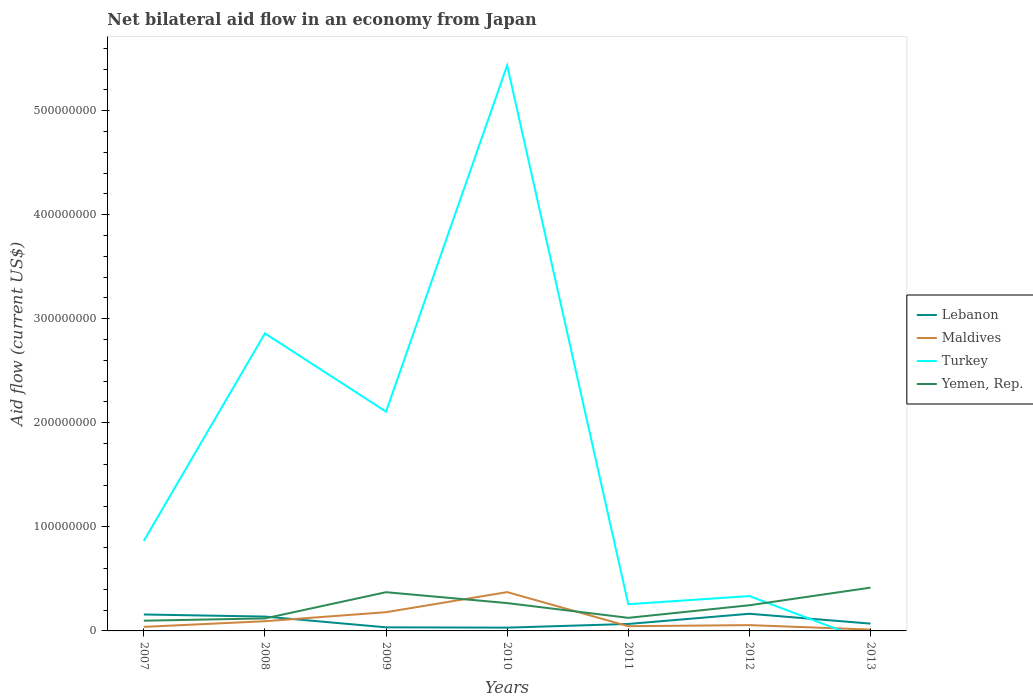How many different coloured lines are there?
Ensure brevity in your answer.  4. Is the number of lines equal to the number of legend labels?
Keep it short and to the point. No. Across all years, what is the maximum net bilateral aid flow in Lebanon?
Give a very brief answer. 3.15e+06. What is the total net bilateral aid flow in Yemen, Rep. in the graph?
Offer a very short reply. -2.96e+07. What is the difference between the highest and the second highest net bilateral aid flow in Turkey?
Make the answer very short. 5.43e+08. How many lines are there?
Make the answer very short. 4. How many years are there in the graph?
Provide a short and direct response. 7. What is the difference between two consecutive major ticks on the Y-axis?
Provide a succinct answer. 1.00e+08. Are the values on the major ticks of Y-axis written in scientific E-notation?
Make the answer very short. No. Where does the legend appear in the graph?
Make the answer very short. Center right. How are the legend labels stacked?
Ensure brevity in your answer.  Vertical. What is the title of the graph?
Your answer should be very brief. Net bilateral aid flow in an economy from Japan. What is the label or title of the X-axis?
Give a very brief answer. Years. What is the Aid flow (current US$) of Lebanon in 2007?
Offer a terse response. 1.58e+07. What is the Aid flow (current US$) of Maldives in 2007?
Your answer should be very brief. 3.89e+06. What is the Aid flow (current US$) of Turkey in 2007?
Ensure brevity in your answer.  8.66e+07. What is the Aid flow (current US$) of Yemen, Rep. in 2007?
Your answer should be very brief. 9.82e+06. What is the Aid flow (current US$) in Lebanon in 2008?
Your response must be concise. 1.38e+07. What is the Aid flow (current US$) in Maldives in 2008?
Keep it short and to the point. 9.32e+06. What is the Aid flow (current US$) of Turkey in 2008?
Give a very brief answer. 2.86e+08. What is the Aid flow (current US$) in Yemen, Rep. in 2008?
Your response must be concise. 1.20e+07. What is the Aid flow (current US$) of Lebanon in 2009?
Offer a very short reply. 3.46e+06. What is the Aid flow (current US$) in Maldives in 2009?
Offer a very short reply. 1.80e+07. What is the Aid flow (current US$) of Turkey in 2009?
Provide a succinct answer. 2.11e+08. What is the Aid flow (current US$) in Yemen, Rep. in 2009?
Make the answer very short. 3.72e+07. What is the Aid flow (current US$) of Lebanon in 2010?
Provide a succinct answer. 3.15e+06. What is the Aid flow (current US$) of Maldives in 2010?
Provide a succinct answer. 3.73e+07. What is the Aid flow (current US$) of Turkey in 2010?
Give a very brief answer. 5.43e+08. What is the Aid flow (current US$) of Yemen, Rep. in 2010?
Offer a very short reply. 2.67e+07. What is the Aid flow (current US$) of Lebanon in 2011?
Keep it short and to the point. 6.69e+06. What is the Aid flow (current US$) of Maldives in 2011?
Keep it short and to the point. 4.55e+06. What is the Aid flow (current US$) of Turkey in 2011?
Your answer should be very brief. 2.57e+07. What is the Aid flow (current US$) of Yemen, Rep. in 2011?
Your response must be concise. 1.26e+07. What is the Aid flow (current US$) of Lebanon in 2012?
Provide a short and direct response. 1.65e+07. What is the Aid flow (current US$) of Maldives in 2012?
Your answer should be compact. 5.57e+06. What is the Aid flow (current US$) of Turkey in 2012?
Provide a succinct answer. 3.35e+07. What is the Aid flow (current US$) of Yemen, Rep. in 2012?
Make the answer very short. 2.47e+07. What is the Aid flow (current US$) in Lebanon in 2013?
Offer a terse response. 7.03e+06. What is the Aid flow (current US$) in Maldives in 2013?
Provide a succinct answer. 1.27e+06. What is the Aid flow (current US$) in Turkey in 2013?
Offer a very short reply. 0. What is the Aid flow (current US$) in Yemen, Rep. in 2013?
Ensure brevity in your answer.  4.16e+07. Across all years, what is the maximum Aid flow (current US$) in Lebanon?
Your answer should be compact. 1.65e+07. Across all years, what is the maximum Aid flow (current US$) in Maldives?
Make the answer very short. 3.73e+07. Across all years, what is the maximum Aid flow (current US$) in Turkey?
Give a very brief answer. 5.43e+08. Across all years, what is the maximum Aid flow (current US$) of Yemen, Rep.?
Offer a terse response. 4.16e+07. Across all years, what is the minimum Aid flow (current US$) of Lebanon?
Your answer should be very brief. 3.15e+06. Across all years, what is the minimum Aid flow (current US$) of Maldives?
Ensure brevity in your answer.  1.27e+06. Across all years, what is the minimum Aid flow (current US$) in Yemen, Rep.?
Make the answer very short. 9.82e+06. What is the total Aid flow (current US$) in Lebanon in the graph?
Offer a very short reply. 6.64e+07. What is the total Aid flow (current US$) of Maldives in the graph?
Offer a terse response. 7.99e+07. What is the total Aid flow (current US$) of Turkey in the graph?
Keep it short and to the point. 1.19e+09. What is the total Aid flow (current US$) of Yemen, Rep. in the graph?
Provide a short and direct response. 1.65e+08. What is the difference between the Aid flow (current US$) of Lebanon in 2007 and that in 2008?
Ensure brevity in your answer.  2.01e+06. What is the difference between the Aid flow (current US$) of Maldives in 2007 and that in 2008?
Give a very brief answer. -5.43e+06. What is the difference between the Aid flow (current US$) in Turkey in 2007 and that in 2008?
Make the answer very short. -1.99e+08. What is the difference between the Aid flow (current US$) in Yemen, Rep. in 2007 and that in 2008?
Give a very brief answer. -2.20e+06. What is the difference between the Aid flow (current US$) of Lebanon in 2007 and that in 2009?
Make the answer very short. 1.23e+07. What is the difference between the Aid flow (current US$) in Maldives in 2007 and that in 2009?
Your response must be concise. -1.41e+07. What is the difference between the Aid flow (current US$) in Turkey in 2007 and that in 2009?
Provide a succinct answer. -1.24e+08. What is the difference between the Aid flow (current US$) in Yemen, Rep. in 2007 and that in 2009?
Ensure brevity in your answer.  -2.74e+07. What is the difference between the Aid flow (current US$) of Lebanon in 2007 and that in 2010?
Keep it short and to the point. 1.26e+07. What is the difference between the Aid flow (current US$) in Maldives in 2007 and that in 2010?
Your response must be concise. -3.34e+07. What is the difference between the Aid flow (current US$) of Turkey in 2007 and that in 2010?
Provide a short and direct response. -4.57e+08. What is the difference between the Aid flow (current US$) in Yemen, Rep. in 2007 and that in 2010?
Offer a terse response. -1.69e+07. What is the difference between the Aid flow (current US$) of Lebanon in 2007 and that in 2011?
Your response must be concise. 9.11e+06. What is the difference between the Aid flow (current US$) in Maldives in 2007 and that in 2011?
Offer a terse response. -6.60e+05. What is the difference between the Aid flow (current US$) of Turkey in 2007 and that in 2011?
Provide a short and direct response. 6.09e+07. What is the difference between the Aid flow (current US$) in Yemen, Rep. in 2007 and that in 2011?
Ensure brevity in your answer.  -2.76e+06. What is the difference between the Aid flow (current US$) of Lebanon in 2007 and that in 2012?
Your answer should be very brief. -6.90e+05. What is the difference between the Aid flow (current US$) in Maldives in 2007 and that in 2012?
Provide a succinct answer. -1.68e+06. What is the difference between the Aid flow (current US$) of Turkey in 2007 and that in 2012?
Your answer should be compact. 5.30e+07. What is the difference between the Aid flow (current US$) of Yemen, Rep. in 2007 and that in 2012?
Keep it short and to the point. -1.48e+07. What is the difference between the Aid flow (current US$) of Lebanon in 2007 and that in 2013?
Your answer should be compact. 8.77e+06. What is the difference between the Aid flow (current US$) in Maldives in 2007 and that in 2013?
Make the answer very short. 2.62e+06. What is the difference between the Aid flow (current US$) of Yemen, Rep. in 2007 and that in 2013?
Keep it short and to the point. -3.18e+07. What is the difference between the Aid flow (current US$) in Lebanon in 2008 and that in 2009?
Give a very brief answer. 1.03e+07. What is the difference between the Aid flow (current US$) of Maldives in 2008 and that in 2009?
Keep it short and to the point. -8.67e+06. What is the difference between the Aid flow (current US$) of Turkey in 2008 and that in 2009?
Ensure brevity in your answer.  7.52e+07. What is the difference between the Aid flow (current US$) in Yemen, Rep. in 2008 and that in 2009?
Your response must be concise. -2.52e+07. What is the difference between the Aid flow (current US$) of Lebanon in 2008 and that in 2010?
Your answer should be compact. 1.06e+07. What is the difference between the Aid flow (current US$) in Maldives in 2008 and that in 2010?
Provide a short and direct response. -2.80e+07. What is the difference between the Aid flow (current US$) of Turkey in 2008 and that in 2010?
Give a very brief answer. -2.58e+08. What is the difference between the Aid flow (current US$) in Yemen, Rep. in 2008 and that in 2010?
Your answer should be compact. -1.47e+07. What is the difference between the Aid flow (current US$) of Lebanon in 2008 and that in 2011?
Ensure brevity in your answer.  7.10e+06. What is the difference between the Aid flow (current US$) in Maldives in 2008 and that in 2011?
Your response must be concise. 4.77e+06. What is the difference between the Aid flow (current US$) in Turkey in 2008 and that in 2011?
Keep it short and to the point. 2.60e+08. What is the difference between the Aid flow (current US$) of Yemen, Rep. in 2008 and that in 2011?
Your response must be concise. -5.60e+05. What is the difference between the Aid flow (current US$) in Lebanon in 2008 and that in 2012?
Give a very brief answer. -2.70e+06. What is the difference between the Aid flow (current US$) of Maldives in 2008 and that in 2012?
Your response must be concise. 3.75e+06. What is the difference between the Aid flow (current US$) in Turkey in 2008 and that in 2012?
Give a very brief answer. 2.52e+08. What is the difference between the Aid flow (current US$) of Yemen, Rep. in 2008 and that in 2012?
Ensure brevity in your answer.  -1.26e+07. What is the difference between the Aid flow (current US$) of Lebanon in 2008 and that in 2013?
Keep it short and to the point. 6.76e+06. What is the difference between the Aid flow (current US$) of Maldives in 2008 and that in 2013?
Provide a succinct answer. 8.05e+06. What is the difference between the Aid flow (current US$) of Yemen, Rep. in 2008 and that in 2013?
Make the answer very short. -2.96e+07. What is the difference between the Aid flow (current US$) in Lebanon in 2009 and that in 2010?
Your answer should be very brief. 3.10e+05. What is the difference between the Aid flow (current US$) of Maldives in 2009 and that in 2010?
Your answer should be compact. -1.93e+07. What is the difference between the Aid flow (current US$) in Turkey in 2009 and that in 2010?
Provide a succinct answer. -3.33e+08. What is the difference between the Aid flow (current US$) in Yemen, Rep. in 2009 and that in 2010?
Provide a short and direct response. 1.05e+07. What is the difference between the Aid flow (current US$) in Lebanon in 2009 and that in 2011?
Provide a succinct answer. -3.23e+06. What is the difference between the Aid flow (current US$) of Maldives in 2009 and that in 2011?
Provide a succinct answer. 1.34e+07. What is the difference between the Aid flow (current US$) in Turkey in 2009 and that in 2011?
Ensure brevity in your answer.  1.85e+08. What is the difference between the Aid flow (current US$) of Yemen, Rep. in 2009 and that in 2011?
Offer a terse response. 2.46e+07. What is the difference between the Aid flow (current US$) of Lebanon in 2009 and that in 2012?
Your answer should be very brief. -1.30e+07. What is the difference between the Aid flow (current US$) of Maldives in 2009 and that in 2012?
Give a very brief answer. 1.24e+07. What is the difference between the Aid flow (current US$) in Turkey in 2009 and that in 2012?
Your response must be concise. 1.77e+08. What is the difference between the Aid flow (current US$) of Yemen, Rep. in 2009 and that in 2012?
Offer a very short reply. 1.25e+07. What is the difference between the Aid flow (current US$) in Lebanon in 2009 and that in 2013?
Ensure brevity in your answer.  -3.57e+06. What is the difference between the Aid flow (current US$) in Maldives in 2009 and that in 2013?
Your answer should be compact. 1.67e+07. What is the difference between the Aid flow (current US$) of Yemen, Rep. in 2009 and that in 2013?
Offer a very short reply. -4.40e+06. What is the difference between the Aid flow (current US$) of Lebanon in 2010 and that in 2011?
Make the answer very short. -3.54e+06. What is the difference between the Aid flow (current US$) of Maldives in 2010 and that in 2011?
Give a very brief answer. 3.28e+07. What is the difference between the Aid flow (current US$) in Turkey in 2010 and that in 2011?
Your answer should be very brief. 5.18e+08. What is the difference between the Aid flow (current US$) of Yemen, Rep. in 2010 and that in 2011?
Give a very brief answer. 1.42e+07. What is the difference between the Aid flow (current US$) of Lebanon in 2010 and that in 2012?
Your response must be concise. -1.33e+07. What is the difference between the Aid flow (current US$) of Maldives in 2010 and that in 2012?
Ensure brevity in your answer.  3.17e+07. What is the difference between the Aid flow (current US$) of Turkey in 2010 and that in 2012?
Provide a succinct answer. 5.10e+08. What is the difference between the Aid flow (current US$) of Yemen, Rep. in 2010 and that in 2012?
Your answer should be compact. 2.07e+06. What is the difference between the Aid flow (current US$) in Lebanon in 2010 and that in 2013?
Offer a terse response. -3.88e+06. What is the difference between the Aid flow (current US$) in Maldives in 2010 and that in 2013?
Make the answer very short. 3.60e+07. What is the difference between the Aid flow (current US$) of Yemen, Rep. in 2010 and that in 2013?
Your answer should be very brief. -1.49e+07. What is the difference between the Aid flow (current US$) in Lebanon in 2011 and that in 2012?
Your answer should be compact. -9.80e+06. What is the difference between the Aid flow (current US$) of Maldives in 2011 and that in 2012?
Give a very brief answer. -1.02e+06. What is the difference between the Aid flow (current US$) in Turkey in 2011 and that in 2012?
Your answer should be very brief. -7.84e+06. What is the difference between the Aid flow (current US$) in Yemen, Rep. in 2011 and that in 2012?
Make the answer very short. -1.21e+07. What is the difference between the Aid flow (current US$) of Maldives in 2011 and that in 2013?
Provide a short and direct response. 3.28e+06. What is the difference between the Aid flow (current US$) of Yemen, Rep. in 2011 and that in 2013?
Give a very brief answer. -2.90e+07. What is the difference between the Aid flow (current US$) in Lebanon in 2012 and that in 2013?
Ensure brevity in your answer.  9.46e+06. What is the difference between the Aid flow (current US$) in Maldives in 2012 and that in 2013?
Provide a short and direct response. 4.30e+06. What is the difference between the Aid flow (current US$) in Yemen, Rep. in 2012 and that in 2013?
Your response must be concise. -1.69e+07. What is the difference between the Aid flow (current US$) of Lebanon in 2007 and the Aid flow (current US$) of Maldives in 2008?
Your answer should be compact. 6.48e+06. What is the difference between the Aid flow (current US$) in Lebanon in 2007 and the Aid flow (current US$) in Turkey in 2008?
Ensure brevity in your answer.  -2.70e+08. What is the difference between the Aid flow (current US$) of Lebanon in 2007 and the Aid flow (current US$) of Yemen, Rep. in 2008?
Keep it short and to the point. 3.78e+06. What is the difference between the Aid flow (current US$) of Maldives in 2007 and the Aid flow (current US$) of Turkey in 2008?
Your answer should be compact. -2.82e+08. What is the difference between the Aid flow (current US$) of Maldives in 2007 and the Aid flow (current US$) of Yemen, Rep. in 2008?
Ensure brevity in your answer.  -8.13e+06. What is the difference between the Aid flow (current US$) in Turkey in 2007 and the Aid flow (current US$) in Yemen, Rep. in 2008?
Ensure brevity in your answer.  7.45e+07. What is the difference between the Aid flow (current US$) in Lebanon in 2007 and the Aid flow (current US$) in Maldives in 2009?
Your answer should be compact. -2.19e+06. What is the difference between the Aid flow (current US$) of Lebanon in 2007 and the Aid flow (current US$) of Turkey in 2009?
Ensure brevity in your answer.  -1.95e+08. What is the difference between the Aid flow (current US$) of Lebanon in 2007 and the Aid flow (current US$) of Yemen, Rep. in 2009?
Provide a short and direct response. -2.14e+07. What is the difference between the Aid flow (current US$) of Maldives in 2007 and the Aid flow (current US$) of Turkey in 2009?
Provide a succinct answer. -2.07e+08. What is the difference between the Aid flow (current US$) in Maldives in 2007 and the Aid flow (current US$) in Yemen, Rep. in 2009?
Keep it short and to the point. -3.33e+07. What is the difference between the Aid flow (current US$) in Turkey in 2007 and the Aid flow (current US$) in Yemen, Rep. in 2009?
Give a very brief answer. 4.93e+07. What is the difference between the Aid flow (current US$) in Lebanon in 2007 and the Aid flow (current US$) in Maldives in 2010?
Your answer should be compact. -2.15e+07. What is the difference between the Aid flow (current US$) of Lebanon in 2007 and the Aid flow (current US$) of Turkey in 2010?
Offer a very short reply. -5.28e+08. What is the difference between the Aid flow (current US$) in Lebanon in 2007 and the Aid flow (current US$) in Yemen, Rep. in 2010?
Your answer should be compact. -1.09e+07. What is the difference between the Aid flow (current US$) of Maldives in 2007 and the Aid flow (current US$) of Turkey in 2010?
Provide a short and direct response. -5.40e+08. What is the difference between the Aid flow (current US$) of Maldives in 2007 and the Aid flow (current US$) of Yemen, Rep. in 2010?
Provide a short and direct response. -2.28e+07. What is the difference between the Aid flow (current US$) of Turkey in 2007 and the Aid flow (current US$) of Yemen, Rep. in 2010?
Offer a terse response. 5.98e+07. What is the difference between the Aid flow (current US$) in Lebanon in 2007 and the Aid flow (current US$) in Maldives in 2011?
Provide a short and direct response. 1.12e+07. What is the difference between the Aid flow (current US$) of Lebanon in 2007 and the Aid flow (current US$) of Turkey in 2011?
Ensure brevity in your answer.  -9.86e+06. What is the difference between the Aid flow (current US$) of Lebanon in 2007 and the Aid flow (current US$) of Yemen, Rep. in 2011?
Ensure brevity in your answer.  3.22e+06. What is the difference between the Aid flow (current US$) in Maldives in 2007 and the Aid flow (current US$) in Turkey in 2011?
Your answer should be compact. -2.18e+07. What is the difference between the Aid flow (current US$) in Maldives in 2007 and the Aid flow (current US$) in Yemen, Rep. in 2011?
Provide a succinct answer. -8.69e+06. What is the difference between the Aid flow (current US$) in Turkey in 2007 and the Aid flow (current US$) in Yemen, Rep. in 2011?
Make the answer very short. 7.40e+07. What is the difference between the Aid flow (current US$) in Lebanon in 2007 and the Aid flow (current US$) in Maldives in 2012?
Provide a succinct answer. 1.02e+07. What is the difference between the Aid flow (current US$) in Lebanon in 2007 and the Aid flow (current US$) in Turkey in 2012?
Offer a terse response. -1.77e+07. What is the difference between the Aid flow (current US$) of Lebanon in 2007 and the Aid flow (current US$) of Yemen, Rep. in 2012?
Your response must be concise. -8.87e+06. What is the difference between the Aid flow (current US$) in Maldives in 2007 and the Aid flow (current US$) in Turkey in 2012?
Your answer should be compact. -2.96e+07. What is the difference between the Aid flow (current US$) in Maldives in 2007 and the Aid flow (current US$) in Yemen, Rep. in 2012?
Your answer should be compact. -2.08e+07. What is the difference between the Aid flow (current US$) in Turkey in 2007 and the Aid flow (current US$) in Yemen, Rep. in 2012?
Provide a succinct answer. 6.19e+07. What is the difference between the Aid flow (current US$) of Lebanon in 2007 and the Aid flow (current US$) of Maldives in 2013?
Give a very brief answer. 1.45e+07. What is the difference between the Aid flow (current US$) in Lebanon in 2007 and the Aid flow (current US$) in Yemen, Rep. in 2013?
Give a very brief answer. -2.58e+07. What is the difference between the Aid flow (current US$) in Maldives in 2007 and the Aid flow (current US$) in Yemen, Rep. in 2013?
Your answer should be compact. -3.77e+07. What is the difference between the Aid flow (current US$) in Turkey in 2007 and the Aid flow (current US$) in Yemen, Rep. in 2013?
Provide a short and direct response. 4.49e+07. What is the difference between the Aid flow (current US$) of Lebanon in 2008 and the Aid flow (current US$) of Maldives in 2009?
Offer a terse response. -4.20e+06. What is the difference between the Aid flow (current US$) of Lebanon in 2008 and the Aid flow (current US$) of Turkey in 2009?
Provide a short and direct response. -1.97e+08. What is the difference between the Aid flow (current US$) of Lebanon in 2008 and the Aid flow (current US$) of Yemen, Rep. in 2009?
Your answer should be compact. -2.34e+07. What is the difference between the Aid flow (current US$) in Maldives in 2008 and the Aid flow (current US$) in Turkey in 2009?
Offer a terse response. -2.01e+08. What is the difference between the Aid flow (current US$) in Maldives in 2008 and the Aid flow (current US$) in Yemen, Rep. in 2009?
Offer a very short reply. -2.79e+07. What is the difference between the Aid flow (current US$) of Turkey in 2008 and the Aid flow (current US$) of Yemen, Rep. in 2009?
Offer a very short reply. 2.49e+08. What is the difference between the Aid flow (current US$) of Lebanon in 2008 and the Aid flow (current US$) of Maldives in 2010?
Offer a terse response. -2.35e+07. What is the difference between the Aid flow (current US$) of Lebanon in 2008 and the Aid flow (current US$) of Turkey in 2010?
Keep it short and to the point. -5.30e+08. What is the difference between the Aid flow (current US$) of Lebanon in 2008 and the Aid flow (current US$) of Yemen, Rep. in 2010?
Offer a terse response. -1.30e+07. What is the difference between the Aid flow (current US$) in Maldives in 2008 and the Aid flow (current US$) in Turkey in 2010?
Provide a short and direct response. -5.34e+08. What is the difference between the Aid flow (current US$) in Maldives in 2008 and the Aid flow (current US$) in Yemen, Rep. in 2010?
Provide a short and direct response. -1.74e+07. What is the difference between the Aid flow (current US$) of Turkey in 2008 and the Aid flow (current US$) of Yemen, Rep. in 2010?
Your answer should be compact. 2.59e+08. What is the difference between the Aid flow (current US$) in Lebanon in 2008 and the Aid flow (current US$) in Maldives in 2011?
Provide a succinct answer. 9.24e+06. What is the difference between the Aid flow (current US$) of Lebanon in 2008 and the Aid flow (current US$) of Turkey in 2011?
Offer a very short reply. -1.19e+07. What is the difference between the Aid flow (current US$) in Lebanon in 2008 and the Aid flow (current US$) in Yemen, Rep. in 2011?
Your answer should be very brief. 1.21e+06. What is the difference between the Aid flow (current US$) of Maldives in 2008 and the Aid flow (current US$) of Turkey in 2011?
Your answer should be very brief. -1.63e+07. What is the difference between the Aid flow (current US$) of Maldives in 2008 and the Aid flow (current US$) of Yemen, Rep. in 2011?
Keep it short and to the point. -3.26e+06. What is the difference between the Aid flow (current US$) of Turkey in 2008 and the Aid flow (current US$) of Yemen, Rep. in 2011?
Provide a succinct answer. 2.73e+08. What is the difference between the Aid flow (current US$) in Lebanon in 2008 and the Aid flow (current US$) in Maldives in 2012?
Your answer should be compact. 8.22e+06. What is the difference between the Aid flow (current US$) in Lebanon in 2008 and the Aid flow (current US$) in Turkey in 2012?
Your answer should be compact. -1.97e+07. What is the difference between the Aid flow (current US$) in Lebanon in 2008 and the Aid flow (current US$) in Yemen, Rep. in 2012?
Provide a short and direct response. -1.09e+07. What is the difference between the Aid flow (current US$) of Maldives in 2008 and the Aid flow (current US$) of Turkey in 2012?
Keep it short and to the point. -2.42e+07. What is the difference between the Aid flow (current US$) of Maldives in 2008 and the Aid flow (current US$) of Yemen, Rep. in 2012?
Offer a very short reply. -1.54e+07. What is the difference between the Aid flow (current US$) of Turkey in 2008 and the Aid flow (current US$) of Yemen, Rep. in 2012?
Your answer should be very brief. 2.61e+08. What is the difference between the Aid flow (current US$) in Lebanon in 2008 and the Aid flow (current US$) in Maldives in 2013?
Keep it short and to the point. 1.25e+07. What is the difference between the Aid flow (current US$) of Lebanon in 2008 and the Aid flow (current US$) of Yemen, Rep. in 2013?
Give a very brief answer. -2.78e+07. What is the difference between the Aid flow (current US$) of Maldives in 2008 and the Aid flow (current US$) of Yemen, Rep. in 2013?
Provide a short and direct response. -3.23e+07. What is the difference between the Aid flow (current US$) of Turkey in 2008 and the Aid flow (current US$) of Yemen, Rep. in 2013?
Your answer should be compact. 2.44e+08. What is the difference between the Aid flow (current US$) of Lebanon in 2009 and the Aid flow (current US$) of Maldives in 2010?
Provide a short and direct response. -3.38e+07. What is the difference between the Aid flow (current US$) in Lebanon in 2009 and the Aid flow (current US$) in Turkey in 2010?
Provide a succinct answer. -5.40e+08. What is the difference between the Aid flow (current US$) of Lebanon in 2009 and the Aid flow (current US$) of Yemen, Rep. in 2010?
Provide a short and direct response. -2.33e+07. What is the difference between the Aid flow (current US$) of Maldives in 2009 and the Aid flow (current US$) of Turkey in 2010?
Keep it short and to the point. -5.26e+08. What is the difference between the Aid flow (current US$) of Maldives in 2009 and the Aid flow (current US$) of Yemen, Rep. in 2010?
Make the answer very short. -8.75e+06. What is the difference between the Aid flow (current US$) of Turkey in 2009 and the Aid flow (current US$) of Yemen, Rep. in 2010?
Offer a very short reply. 1.84e+08. What is the difference between the Aid flow (current US$) in Lebanon in 2009 and the Aid flow (current US$) in Maldives in 2011?
Keep it short and to the point. -1.09e+06. What is the difference between the Aid flow (current US$) in Lebanon in 2009 and the Aid flow (current US$) in Turkey in 2011?
Ensure brevity in your answer.  -2.22e+07. What is the difference between the Aid flow (current US$) in Lebanon in 2009 and the Aid flow (current US$) in Yemen, Rep. in 2011?
Your answer should be very brief. -9.12e+06. What is the difference between the Aid flow (current US$) in Maldives in 2009 and the Aid flow (current US$) in Turkey in 2011?
Give a very brief answer. -7.67e+06. What is the difference between the Aid flow (current US$) in Maldives in 2009 and the Aid flow (current US$) in Yemen, Rep. in 2011?
Your response must be concise. 5.41e+06. What is the difference between the Aid flow (current US$) of Turkey in 2009 and the Aid flow (current US$) of Yemen, Rep. in 2011?
Give a very brief answer. 1.98e+08. What is the difference between the Aid flow (current US$) of Lebanon in 2009 and the Aid flow (current US$) of Maldives in 2012?
Ensure brevity in your answer.  -2.11e+06. What is the difference between the Aid flow (current US$) in Lebanon in 2009 and the Aid flow (current US$) in Turkey in 2012?
Your answer should be compact. -3.00e+07. What is the difference between the Aid flow (current US$) in Lebanon in 2009 and the Aid flow (current US$) in Yemen, Rep. in 2012?
Provide a succinct answer. -2.12e+07. What is the difference between the Aid flow (current US$) in Maldives in 2009 and the Aid flow (current US$) in Turkey in 2012?
Give a very brief answer. -1.55e+07. What is the difference between the Aid flow (current US$) in Maldives in 2009 and the Aid flow (current US$) in Yemen, Rep. in 2012?
Give a very brief answer. -6.68e+06. What is the difference between the Aid flow (current US$) of Turkey in 2009 and the Aid flow (current US$) of Yemen, Rep. in 2012?
Your answer should be compact. 1.86e+08. What is the difference between the Aid flow (current US$) in Lebanon in 2009 and the Aid flow (current US$) in Maldives in 2013?
Keep it short and to the point. 2.19e+06. What is the difference between the Aid flow (current US$) in Lebanon in 2009 and the Aid flow (current US$) in Yemen, Rep. in 2013?
Your answer should be very brief. -3.82e+07. What is the difference between the Aid flow (current US$) of Maldives in 2009 and the Aid flow (current US$) of Yemen, Rep. in 2013?
Provide a short and direct response. -2.36e+07. What is the difference between the Aid flow (current US$) of Turkey in 2009 and the Aid flow (current US$) of Yemen, Rep. in 2013?
Give a very brief answer. 1.69e+08. What is the difference between the Aid flow (current US$) in Lebanon in 2010 and the Aid flow (current US$) in Maldives in 2011?
Your response must be concise. -1.40e+06. What is the difference between the Aid flow (current US$) in Lebanon in 2010 and the Aid flow (current US$) in Turkey in 2011?
Offer a terse response. -2.25e+07. What is the difference between the Aid flow (current US$) in Lebanon in 2010 and the Aid flow (current US$) in Yemen, Rep. in 2011?
Your answer should be very brief. -9.43e+06. What is the difference between the Aid flow (current US$) of Maldives in 2010 and the Aid flow (current US$) of Turkey in 2011?
Provide a short and direct response. 1.16e+07. What is the difference between the Aid flow (current US$) of Maldives in 2010 and the Aid flow (current US$) of Yemen, Rep. in 2011?
Make the answer very short. 2.47e+07. What is the difference between the Aid flow (current US$) of Turkey in 2010 and the Aid flow (current US$) of Yemen, Rep. in 2011?
Offer a very short reply. 5.31e+08. What is the difference between the Aid flow (current US$) of Lebanon in 2010 and the Aid flow (current US$) of Maldives in 2012?
Your answer should be compact. -2.42e+06. What is the difference between the Aid flow (current US$) in Lebanon in 2010 and the Aid flow (current US$) in Turkey in 2012?
Your answer should be very brief. -3.04e+07. What is the difference between the Aid flow (current US$) of Lebanon in 2010 and the Aid flow (current US$) of Yemen, Rep. in 2012?
Offer a terse response. -2.15e+07. What is the difference between the Aid flow (current US$) in Maldives in 2010 and the Aid flow (current US$) in Turkey in 2012?
Your response must be concise. 3.80e+06. What is the difference between the Aid flow (current US$) in Maldives in 2010 and the Aid flow (current US$) in Yemen, Rep. in 2012?
Offer a terse response. 1.26e+07. What is the difference between the Aid flow (current US$) of Turkey in 2010 and the Aid flow (current US$) of Yemen, Rep. in 2012?
Give a very brief answer. 5.19e+08. What is the difference between the Aid flow (current US$) in Lebanon in 2010 and the Aid flow (current US$) in Maldives in 2013?
Your answer should be very brief. 1.88e+06. What is the difference between the Aid flow (current US$) in Lebanon in 2010 and the Aid flow (current US$) in Yemen, Rep. in 2013?
Keep it short and to the point. -3.85e+07. What is the difference between the Aid flow (current US$) in Maldives in 2010 and the Aid flow (current US$) in Yemen, Rep. in 2013?
Provide a succinct answer. -4.31e+06. What is the difference between the Aid flow (current US$) of Turkey in 2010 and the Aid flow (current US$) of Yemen, Rep. in 2013?
Ensure brevity in your answer.  5.02e+08. What is the difference between the Aid flow (current US$) of Lebanon in 2011 and the Aid flow (current US$) of Maldives in 2012?
Give a very brief answer. 1.12e+06. What is the difference between the Aid flow (current US$) in Lebanon in 2011 and the Aid flow (current US$) in Turkey in 2012?
Give a very brief answer. -2.68e+07. What is the difference between the Aid flow (current US$) in Lebanon in 2011 and the Aid flow (current US$) in Yemen, Rep. in 2012?
Give a very brief answer. -1.80e+07. What is the difference between the Aid flow (current US$) in Maldives in 2011 and the Aid flow (current US$) in Turkey in 2012?
Offer a very short reply. -2.90e+07. What is the difference between the Aid flow (current US$) of Maldives in 2011 and the Aid flow (current US$) of Yemen, Rep. in 2012?
Offer a terse response. -2.01e+07. What is the difference between the Aid flow (current US$) in Turkey in 2011 and the Aid flow (current US$) in Yemen, Rep. in 2012?
Keep it short and to the point. 9.90e+05. What is the difference between the Aid flow (current US$) of Lebanon in 2011 and the Aid flow (current US$) of Maldives in 2013?
Provide a succinct answer. 5.42e+06. What is the difference between the Aid flow (current US$) of Lebanon in 2011 and the Aid flow (current US$) of Yemen, Rep. in 2013?
Your answer should be compact. -3.49e+07. What is the difference between the Aid flow (current US$) of Maldives in 2011 and the Aid flow (current US$) of Yemen, Rep. in 2013?
Provide a short and direct response. -3.71e+07. What is the difference between the Aid flow (current US$) of Turkey in 2011 and the Aid flow (current US$) of Yemen, Rep. in 2013?
Your response must be concise. -1.60e+07. What is the difference between the Aid flow (current US$) in Lebanon in 2012 and the Aid flow (current US$) in Maldives in 2013?
Provide a succinct answer. 1.52e+07. What is the difference between the Aid flow (current US$) of Lebanon in 2012 and the Aid flow (current US$) of Yemen, Rep. in 2013?
Give a very brief answer. -2.51e+07. What is the difference between the Aid flow (current US$) of Maldives in 2012 and the Aid flow (current US$) of Yemen, Rep. in 2013?
Give a very brief answer. -3.60e+07. What is the difference between the Aid flow (current US$) in Turkey in 2012 and the Aid flow (current US$) in Yemen, Rep. in 2013?
Make the answer very short. -8.11e+06. What is the average Aid flow (current US$) of Lebanon per year?
Offer a very short reply. 9.49e+06. What is the average Aid flow (current US$) in Maldives per year?
Provide a short and direct response. 1.14e+07. What is the average Aid flow (current US$) of Turkey per year?
Your answer should be compact. 1.69e+08. What is the average Aid flow (current US$) of Yemen, Rep. per year?
Make the answer very short. 2.35e+07. In the year 2007, what is the difference between the Aid flow (current US$) of Lebanon and Aid flow (current US$) of Maldives?
Keep it short and to the point. 1.19e+07. In the year 2007, what is the difference between the Aid flow (current US$) in Lebanon and Aid flow (current US$) in Turkey?
Keep it short and to the point. -7.08e+07. In the year 2007, what is the difference between the Aid flow (current US$) in Lebanon and Aid flow (current US$) in Yemen, Rep.?
Your answer should be very brief. 5.98e+06. In the year 2007, what is the difference between the Aid flow (current US$) in Maldives and Aid flow (current US$) in Turkey?
Make the answer very short. -8.27e+07. In the year 2007, what is the difference between the Aid flow (current US$) in Maldives and Aid flow (current US$) in Yemen, Rep.?
Give a very brief answer. -5.93e+06. In the year 2007, what is the difference between the Aid flow (current US$) in Turkey and Aid flow (current US$) in Yemen, Rep.?
Provide a short and direct response. 7.67e+07. In the year 2008, what is the difference between the Aid flow (current US$) in Lebanon and Aid flow (current US$) in Maldives?
Provide a succinct answer. 4.47e+06. In the year 2008, what is the difference between the Aid flow (current US$) in Lebanon and Aid flow (current US$) in Turkey?
Offer a very short reply. -2.72e+08. In the year 2008, what is the difference between the Aid flow (current US$) of Lebanon and Aid flow (current US$) of Yemen, Rep.?
Give a very brief answer. 1.77e+06. In the year 2008, what is the difference between the Aid flow (current US$) of Maldives and Aid flow (current US$) of Turkey?
Offer a terse response. -2.77e+08. In the year 2008, what is the difference between the Aid flow (current US$) in Maldives and Aid flow (current US$) in Yemen, Rep.?
Offer a terse response. -2.70e+06. In the year 2008, what is the difference between the Aid flow (current US$) of Turkey and Aid flow (current US$) of Yemen, Rep.?
Offer a terse response. 2.74e+08. In the year 2009, what is the difference between the Aid flow (current US$) in Lebanon and Aid flow (current US$) in Maldives?
Provide a succinct answer. -1.45e+07. In the year 2009, what is the difference between the Aid flow (current US$) in Lebanon and Aid flow (current US$) in Turkey?
Your answer should be compact. -2.07e+08. In the year 2009, what is the difference between the Aid flow (current US$) of Lebanon and Aid flow (current US$) of Yemen, Rep.?
Offer a very short reply. -3.38e+07. In the year 2009, what is the difference between the Aid flow (current US$) in Maldives and Aid flow (current US$) in Turkey?
Ensure brevity in your answer.  -1.93e+08. In the year 2009, what is the difference between the Aid flow (current US$) of Maldives and Aid flow (current US$) of Yemen, Rep.?
Keep it short and to the point. -1.92e+07. In the year 2009, what is the difference between the Aid flow (current US$) in Turkey and Aid flow (current US$) in Yemen, Rep.?
Provide a short and direct response. 1.74e+08. In the year 2010, what is the difference between the Aid flow (current US$) of Lebanon and Aid flow (current US$) of Maldives?
Offer a terse response. -3.42e+07. In the year 2010, what is the difference between the Aid flow (current US$) in Lebanon and Aid flow (current US$) in Turkey?
Provide a short and direct response. -5.40e+08. In the year 2010, what is the difference between the Aid flow (current US$) in Lebanon and Aid flow (current US$) in Yemen, Rep.?
Give a very brief answer. -2.36e+07. In the year 2010, what is the difference between the Aid flow (current US$) of Maldives and Aid flow (current US$) of Turkey?
Give a very brief answer. -5.06e+08. In the year 2010, what is the difference between the Aid flow (current US$) of Maldives and Aid flow (current US$) of Yemen, Rep.?
Make the answer very short. 1.06e+07. In the year 2010, what is the difference between the Aid flow (current US$) in Turkey and Aid flow (current US$) in Yemen, Rep.?
Keep it short and to the point. 5.17e+08. In the year 2011, what is the difference between the Aid flow (current US$) in Lebanon and Aid flow (current US$) in Maldives?
Ensure brevity in your answer.  2.14e+06. In the year 2011, what is the difference between the Aid flow (current US$) in Lebanon and Aid flow (current US$) in Turkey?
Give a very brief answer. -1.90e+07. In the year 2011, what is the difference between the Aid flow (current US$) of Lebanon and Aid flow (current US$) of Yemen, Rep.?
Give a very brief answer. -5.89e+06. In the year 2011, what is the difference between the Aid flow (current US$) of Maldives and Aid flow (current US$) of Turkey?
Your answer should be very brief. -2.11e+07. In the year 2011, what is the difference between the Aid flow (current US$) in Maldives and Aid flow (current US$) in Yemen, Rep.?
Provide a succinct answer. -8.03e+06. In the year 2011, what is the difference between the Aid flow (current US$) in Turkey and Aid flow (current US$) in Yemen, Rep.?
Offer a terse response. 1.31e+07. In the year 2012, what is the difference between the Aid flow (current US$) in Lebanon and Aid flow (current US$) in Maldives?
Your answer should be very brief. 1.09e+07. In the year 2012, what is the difference between the Aid flow (current US$) in Lebanon and Aid flow (current US$) in Turkey?
Ensure brevity in your answer.  -1.70e+07. In the year 2012, what is the difference between the Aid flow (current US$) in Lebanon and Aid flow (current US$) in Yemen, Rep.?
Provide a succinct answer. -8.18e+06. In the year 2012, what is the difference between the Aid flow (current US$) of Maldives and Aid flow (current US$) of Turkey?
Ensure brevity in your answer.  -2.79e+07. In the year 2012, what is the difference between the Aid flow (current US$) in Maldives and Aid flow (current US$) in Yemen, Rep.?
Keep it short and to the point. -1.91e+07. In the year 2012, what is the difference between the Aid flow (current US$) in Turkey and Aid flow (current US$) in Yemen, Rep.?
Offer a terse response. 8.83e+06. In the year 2013, what is the difference between the Aid flow (current US$) in Lebanon and Aid flow (current US$) in Maldives?
Provide a short and direct response. 5.76e+06. In the year 2013, what is the difference between the Aid flow (current US$) of Lebanon and Aid flow (current US$) of Yemen, Rep.?
Ensure brevity in your answer.  -3.46e+07. In the year 2013, what is the difference between the Aid flow (current US$) of Maldives and Aid flow (current US$) of Yemen, Rep.?
Your answer should be very brief. -4.03e+07. What is the ratio of the Aid flow (current US$) in Lebanon in 2007 to that in 2008?
Provide a short and direct response. 1.15. What is the ratio of the Aid flow (current US$) of Maldives in 2007 to that in 2008?
Offer a very short reply. 0.42. What is the ratio of the Aid flow (current US$) in Turkey in 2007 to that in 2008?
Offer a very short reply. 0.3. What is the ratio of the Aid flow (current US$) in Yemen, Rep. in 2007 to that in 2008?
Provide a succinct answer. 0.82. What is the ratio of the Aid flow (current US$) of Lebanon in 2007 to that in 2009?
Your answer should be compact. 4.57. What is the ratio of the Aid flow (current US$) in Maldives in 2007 to that in 2009?
Offer a very short reply. 0.22. What is the ratio of the Aid flow (current US$) of Turkey in 2007 to that in 2009?
Make the answer very short. 0.41. What is the ratio of the Aid flow (current US$) of Yemen, Rep. in 2007 to that in 2009?
Your response must be concise. 0.26. What is the ratio of the Aid flow (current US$) of Lebanon in 2007 to that in 2010?
Ensure brevity in your answer.  5.02. What is the ratio of the Aid flow (current US$) in Maldives in 2007 to that in 2010?
Provide a short and direct response. 0.1. What is the ratio of the Aid flow (current US$) of Turkey in 2007 to that in 2010?
Provide a short and direct response. 0.16. What is the ratio of the Aid flow (current US$) in Yemen, Rep. in 2007 to that in 2010?
Your answer should be compact. 0.37. What is the ratio of the Aid flow (current US$) in Lebanon in 2007 to that in 2011?
Provide a short and direct response. 2.36. What is the ratio of the Aid flow (current US$) of Maldives in 2007 to that in 2011?
Keep it short and to the point. 0.85. What is the ratio of the Aid flow (current US$) in Turkey in 2007 to that in 2011?
Offer a very short reply. 3.37. What is the ratio of the Aid flow (current US$) of Yemen, Rep. in 2007 to that in 2011?
Provide a short and direct response. 0.78. What is the ratio of the Aid flow (current US$) in Lebanon in 2007 to that in 2012?
Your answer should be very brief. 0.96. What is the ratio of the Aid flow (current US$) of Maldives in 2007 to that in 2012?
Offer a terse response. 0.7. What is the ratio of the Aid flow (current US$) of Turkey in 2007 to that in 2012?
Provide a succinct answer. 2.58. What is the ratio of the Aid flow (current US$) of Yemen, Rep. in 2007 to that in 2012?
Provide a succinct answer. 0.4. What is the ratio of the Aid flow (current US$) of Lebanon in 2007 to that in 2013?
Provide a short and direct response. 2.25. What is the ratio of the Aid flow (current US$) in Maldives in 2007 to that in 2013?
Your answer should be very brief. 3.06. What is the ratio of the Aid flow (current US$) of Yemen, Rep. in 2007 to that in 2013?
Ensure brevity in your answer.  0.24. What is the ratio of the Aid flow (current US$) in Lebanon in 2008 to that in 2009?
Provide a short and direct response. 3.99. What is the ratio of the Aid flow (current US$) of Maldives in 2008 to that in 2009?
Provide a short and direct response. 0.52. What is the ratio of the Aid flow (current US$) of Turkey in 2008 to that in 2009?
Give a very brief answer. 1.36. What is the ratio of the Aid flow (current US$) of Yemen, Rep. in 2008 to that in 2009?
Your response must be concise. 0.32. What is the ratio of the Aid flow (current US$) in Lebanon in 2008 to that in 2010?
Offer a very short reply. 4.38. What is the ratio of the Aid flow (current US$) in Maldives in 2008 to that in 2010?
Ensure brevity in your answer.  0.25. What is the ratio of the Aid flow (current US$) of Turkey in 2008 to that in 2010?
Offer a terse response. 0.53. What is the ratio of the Aid flow (current US$) in Yemen, Rep. in 2008 to that in 2010?
Keep it short and to the point. 0.45. What is the ratio of the Aid flow (current US$) of Lebanon in 2008 to that in 2011?
Offer a terse response. 2.06. What is the ratio of the Aid flow (current US$) in Maldives in 2008 to that in 2011?
Provide a succinct answer. 2.05. What is the ratio of the Aid flow (current US$) of Turkey in 2008 to that in 2011?
Your answer should be very brief. 11.14. What is the ratio of the Aid flow (current US$) in Yemen, Rep. in 2008 to that in 2011?
Your answer should be very brief. 0.96. What is the ratio of the Aid flow (current US$) in Lebanon in 2008 to that in 2012?
Your response must be concise. 0.84. What is the ratio of the Aid flow (current US$) of Maldives in 2008 to that in 2012?
Keep it short and to the point. 1.67. What is the ratio of the Aid flow (current US$) in Turkey in 2008 to that in 2012?
Your answer should be very brief. 8.53. What is the ratio of the Aid flow (current US$) of Yemen, Rep. in 2008 to that in 2012?
Offer a very short reply. 0.49. What is the ratio of the Aid flow (current US$) in Lebanon in 2008 to that in 2013?
Ensure brevity in your answer.  1.96. What is the ratio of the Aid flow (current US$) in Maldives in 2008 to that in 2013?
Your response must be concise. 7.34. What is the ratio of the Aid flow (current US$) of Yemen, Rep. in 2008 to that in 2013?
Give a very brief answer. 0.29. What is the ratio of the Aid flow (current US$) in Lebanon in 2009 to that in 2010?
Your answer should be compact. 1.1. What is the ratio of the Aid flow (current US$) in Maldives in 2009 to that in 2010?
Provide a succinct answer. 0.48. What is the ratio of the Aid flow (current US$) of Turkey in 2009 to that in 2010?
Offer a terse response. 0.39. What is the ratio of the Aid flow (current US$) in Yemen, Rep. in 2009 to that in 2010?
Your response must be concise. 1.39. What is the ratio of the Aid flow (current US$) in Lebanon in 2009 to that in 2011?
Provide a short and direct response. 0.52. What is the ratio of the Aid flow (current US$) in Maldives in 2009 to that in 2011?
Give a very brief answer. 3.95. What is the ratio of the Aid flow (current US$) in Turkey in 2009 to that in 2011?
Offer a very short reply. 8.21. What is the ratio of the Aid flow (current US$) of Yemen, Rep. in 2009 to that in 2011?
Provide a short and direct response. 2.96. What is the ratio of the Aid flow (current US$) of Lebanon in 2009 to that in 2012?
Your answer should be compact. 0.21. What is the ratio of the Aid flow (current US$) in Maldives in 2009 to that in 2012?
Offer a terse response. 3.23. What is the ratio of the Aid flow (current US$) of Turkey in 2009 to that in 2012?
Provide a short and direct response. 6.29. What is the ratio of the Aid flow (current US$) of Yemen, Rep. in 2009 to that in 2012?
Keep it short and to the point. 1.51. What is the ratio of the Aid flow (current US$) of Lebanon in 2009 to that in 2013?
Offer a very short reply. 0.49. What is the ratio of the Aid flow (current US$) of Maldives in 2009 to that in 2013?
Ensure brevity in your answer.  14.17. What is the ratio of the Aid flow (current US$) of Yemen, Rep. in 2009 to that in 2013?
Your answer should be compact. 0.89. What is the ratio of the Aid flow (current US$) of Lebanon in 2010 to that in 2011?
Your answer should be compact. 0.47. What is the ratio of the Aid flow (current US$) of Maldives in 2010 to that in 2011?
Keep it short and to the point. 8.2. What is the ratio of the Aid flow (current US$) of Turkey in 2010 to that in 2011?
Keep it short and to the point. 21.18. What is the ratio of the Aid flow (current US$) of Yemen, Rep. in 2010 to that in 2011?
Offer a terse response. 2.13. What is the ratio of the Aid flow (current US$) of Lebanon in 2010 to that in 2012?
Provide a succinct answer. 0.19. What is the ratio of the Aid flow (current US$) of Maldives in 2010 to that in 2012?
Offer a terse response. 6.7. What is the ratio of the Aid flow (current US$) in Turkey in 2010 to that in 2012?
Your answer should be very brief. 16.22. What is the ratio of the Aid flow (current US$) in Yemen, Rep. in 2010 to that in 2012?
Give a very brief answer. 1.08. What is the ratio of the Aid flow (current US$) of Lebanon in 2010 to that in 2013?
Keep it short and to the point. 0.45. What is the ratio of the Aid flow (current US$) in Maldives in 2010 to that in 2013?
Offer a terse response. 29.37. What is the ratio of the Aid flow (current US$) of Yemen, Rep. in 2010 to that in 2013?
Your response must be concise. 0.64. What is the ratio of the Aid flow (current US$) in Lebanon in 2011 to that in 2012?
Give a very brief answer. 0.41. What is the ratio of the Aid flow (current US$) of Maldives in 2011 to that in 2012?
Your answer should be very brief. 0.82. What is the ratio of the Aid flow (current US$) in Turkey in 2011 to that in 2012?
Give a very brief answer. 0.77. What is the ratio of the Aid flow (current US$) in Yemen, Rep. in 2011 to that in 2012?
Offer a very short reply. 0.51. What is the ratio of the Aid flow (current US$) in Lebanon in 2011 to that in 2013?
Make the answer very short. 0.95. What is the ratio of the Aid flow (current US$) in Maldives in 2011 to that in 2013?
Your response must be concise. 3.58. What is the ratio of the Aid flow (current US$) of Yemen, Rep. in 2011 to that in 2013?
Your response must be concise. 0.3. What is the ratio of the Aid flow (current US$) in Lebanon in 2012 to that in 2013?
Your answer should be very brief. 2.35. What is the ratio of the Aid flow (current US$) of Maldives in 2012 to that in 2013?
Provide a short and direct response. 4.39. What is the ratio of the Aid flow (current US$) of Yemen, Rep. in 2012 to that in 2013?
Your response must be concise. 0.59. What is the difference between the highest and the second highest Aid flow (current US$) in Lebanon?
Keep it short and to the point. 6.90e+05. What is the difference between the highest and the second highest Aid flow (current US$) of Maldives?
Make the answer very short. 1.93e+07. What is the difference between the highest and the second highest Aid flow (current US$) in Turkey?
Offer a terse response. 2.58e+08. What is the difference between the highest and the second highest Aid flow (current US$) in Yemen, Rep.?
Provide a succinct answer. 4.40e+06. What is the difference between the highest and the lowest Aid flow (current US$) of Lebanon?
Keep it short and to the point. 1.33e+07. What is the difference between the highest and the lowest Aid flow (current US$) in Maldives?
Provide a succinct answer. 3.60e+07. What is the difference between the highest and the lowest Aid flow (current US$) in Turkey?
Offer a very short reply. 5.43e+08. What is the difference between the highest and the lowest Aid flow (current US$) of Yemen, Rep.?
Provide a succinct answer. 3.18e+07. 